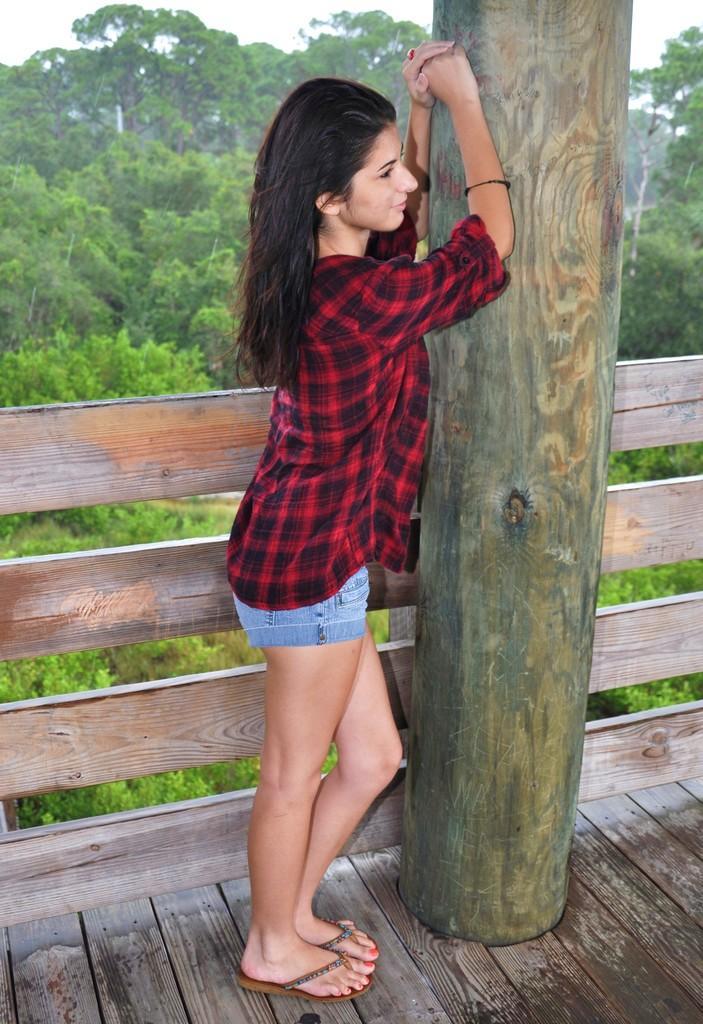In one or two sentences, can you explain what this image depicts? In this image there is the sky towards the top of the image, there are trees, there is a wooden pillar, there is a woman standing, there is a wooden floor towards the bottom of the image. 